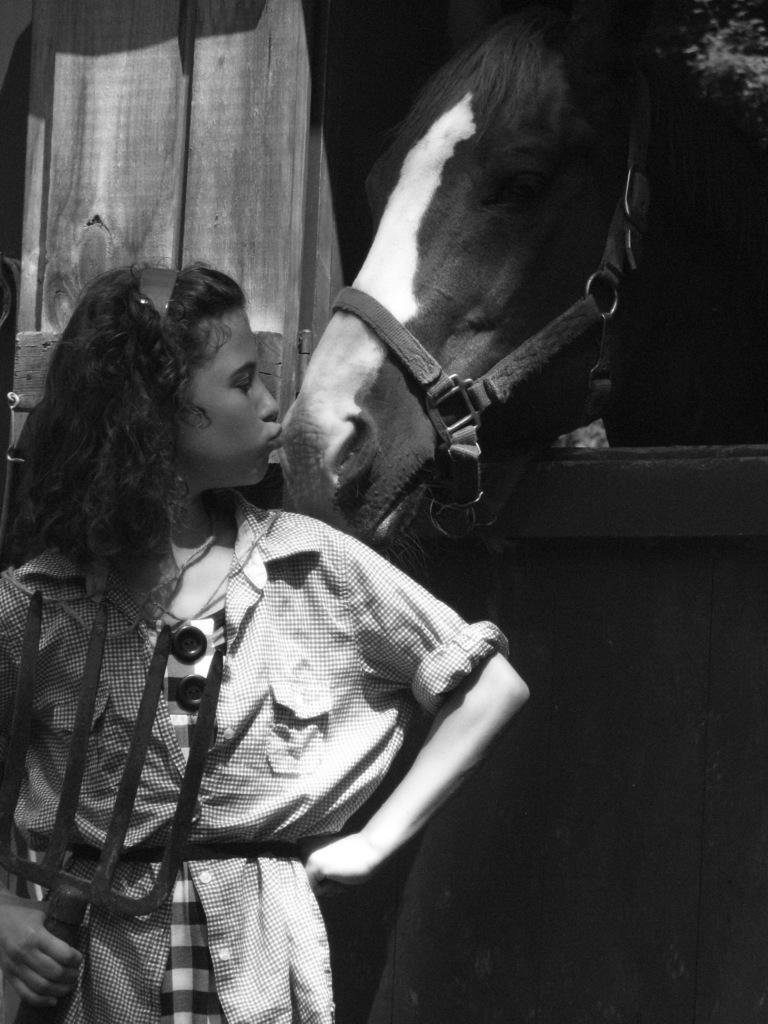Describe this image in one or two sentences. Here we can see a girl is standing and holding an object in her hand, and she is kissing to the horse. 